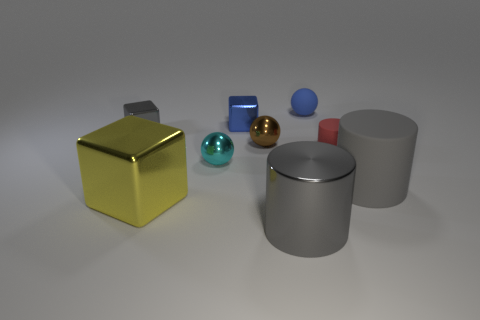Subtract all metallic cylinders. How many cylinders are left? 2 Subtract all blue cubes. How many gray cylinders are left? 2 Subtract 1 spheres. How many spheres are left? 2 Subtract all balls. How many objects are left? 6 Subtract all yellow balls. Subtract all brown cubes. How many balls are left? 3 Add 8 tiny brown shiny cylinders. How many tiny brown shiny cylinders exist? 8 Subtract 1 blue cubes. How many objects are left? 8 Subtract all tiny objects. Subtract all big matte cylinders. How many objects are left? 2 Add 9 tiny blue matte objects. How many tiny blue matte objects are left? 10 